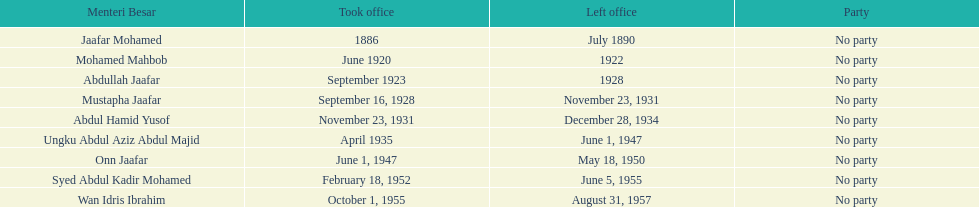What are all the people that were menteri besar of johor? Jaafar Mohamed, Mohamed Mahbob, Abdullah Jaafar, Mustapha Jaafar, Abdul Hamid Yusof, Ungku Abdul Aziz Abdul Majid, Onn Jaafar, Syed Abdul Kadir Mohamed, Wan Idris Ibrahim. Who ruled the longest? Ungku Abdul Aziz Abdul Majid. 